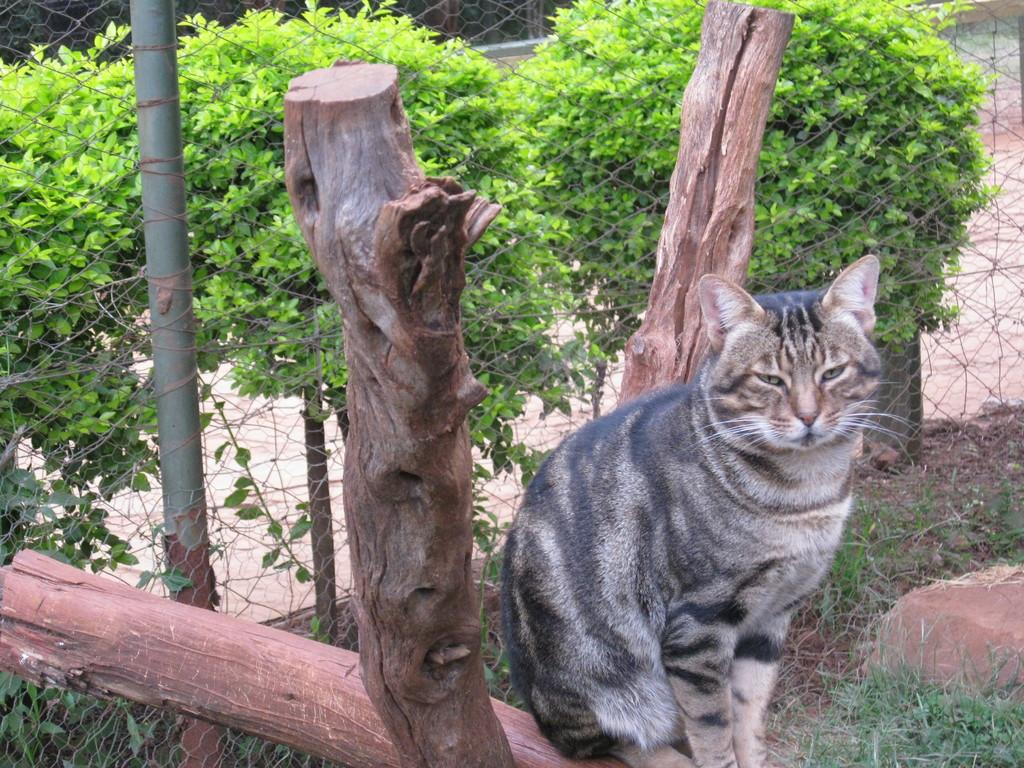What animal can be seen in the image? There is a cat in the image. Where is the cat located? The cat is sitting on a log. What type of structure is present in the image? There is fencing in the image. What type of vegetation is visible in the image? There are small trees in the image. What type of fuel is the cat using to power its movements in the image? The cat does not use fuel to power its movements in the image; it is a living animal. Is there a plough visible in the image? No, there is no plough present in the image. 